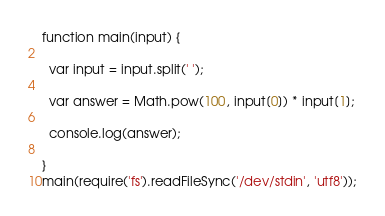Convert code to text. <code><loc_0><loc_0><loc_500><loc_500><_JavaScript_>function main(input) {

  var input = input.split(' ');

  var answer = Math.pow(100, input[0]) * input[1];

  console.log(answer);

}
main(require('fs').readFileSync('/dev/stdin', 'utf8'));</code> 